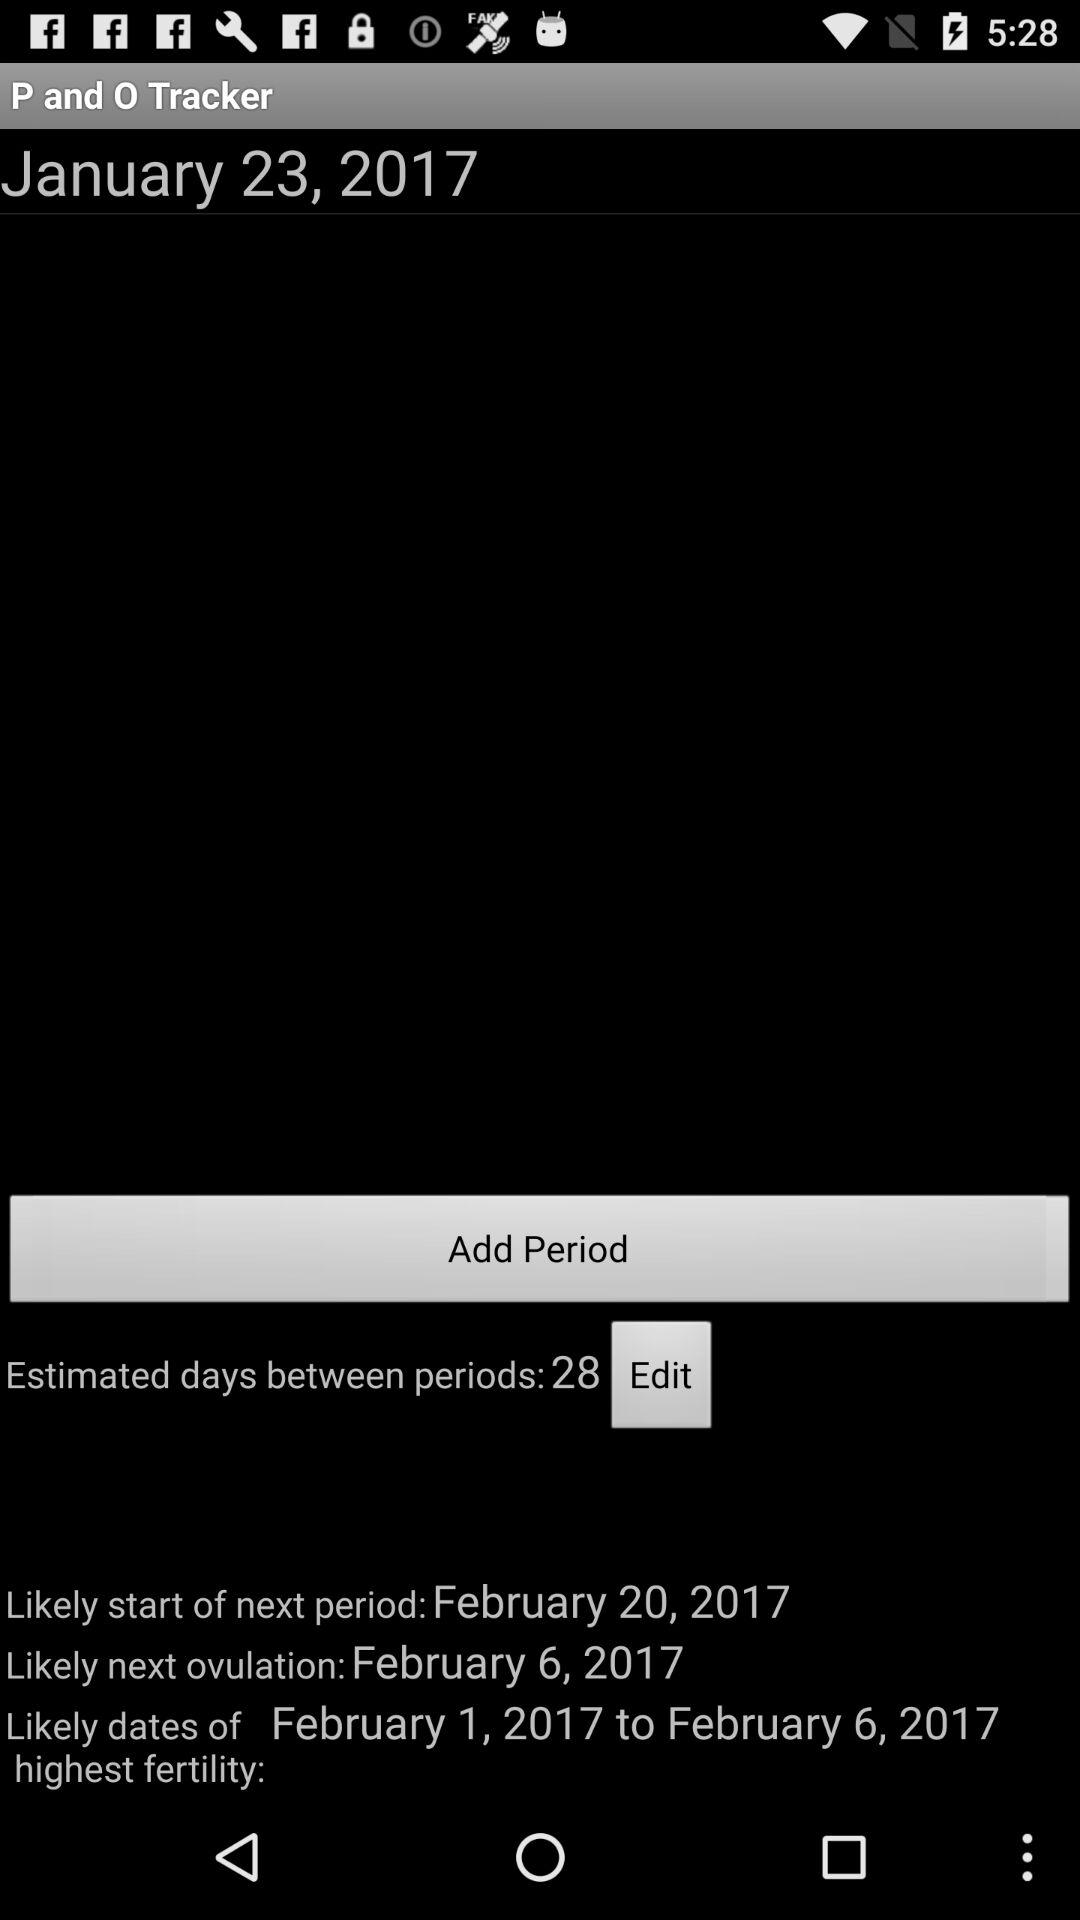When is the next period likely to start? The next period is likely to start on February 20, 2017. 